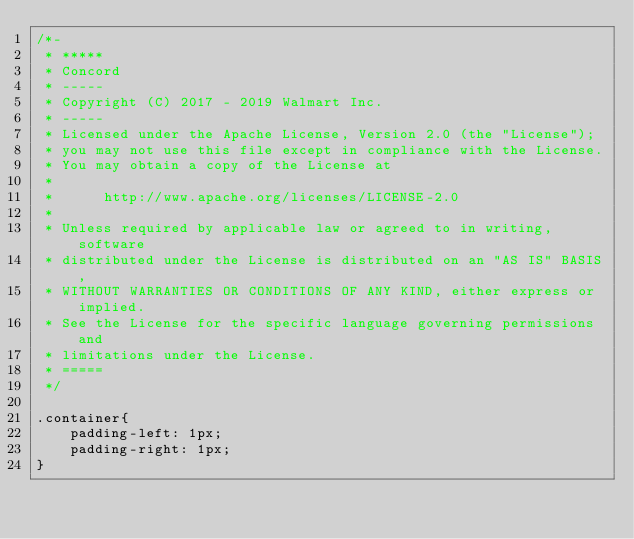<code> <loc_0><loc_0><loc_500><loc_500><_CSS_>/*-
 * *****
 * Concord
 * -----
 * Copyright (C) 2017 - 2019 Walmart Inc.
 * -----
 * Licensed under the Apache License, Version 2.0 (the "License");
 * you may not use this file except in compliance with the License.
 * You may obtain a copy of the License at
 * 
 *      http://www.apache.org/licenses/LICENSE-2.0
 * 
 * Unless required by applicable law or agreed to in writing, software
 * distributed under the License is distributed on an "AS IS" BASIS,
 * WITHOUT WARRANTIES OR CONDITIONS OF ANY KIND, either express or implied.
 * See the License for the specific language governing permissions and
 * limitations under the License.
 * =====
 */

.container{
    padding-left: 1px;
    padding-right: 1px;
}
</code> 